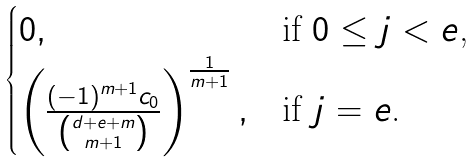<formula> <loc_0><loc_0><loc_500><loc_500>\begin{cases} 0 , & \text {if $0 \leq j <e$,} \\ \left ( \frac { ( - 1 ) ^ { m + 1 } c _ { 0 } } { \binom { d + e + m } { m + 1 } } \right ) ^ { \frac { 1 } { m + 1 } } , & \text {if $j=e$.} \end{cases}</formula> 